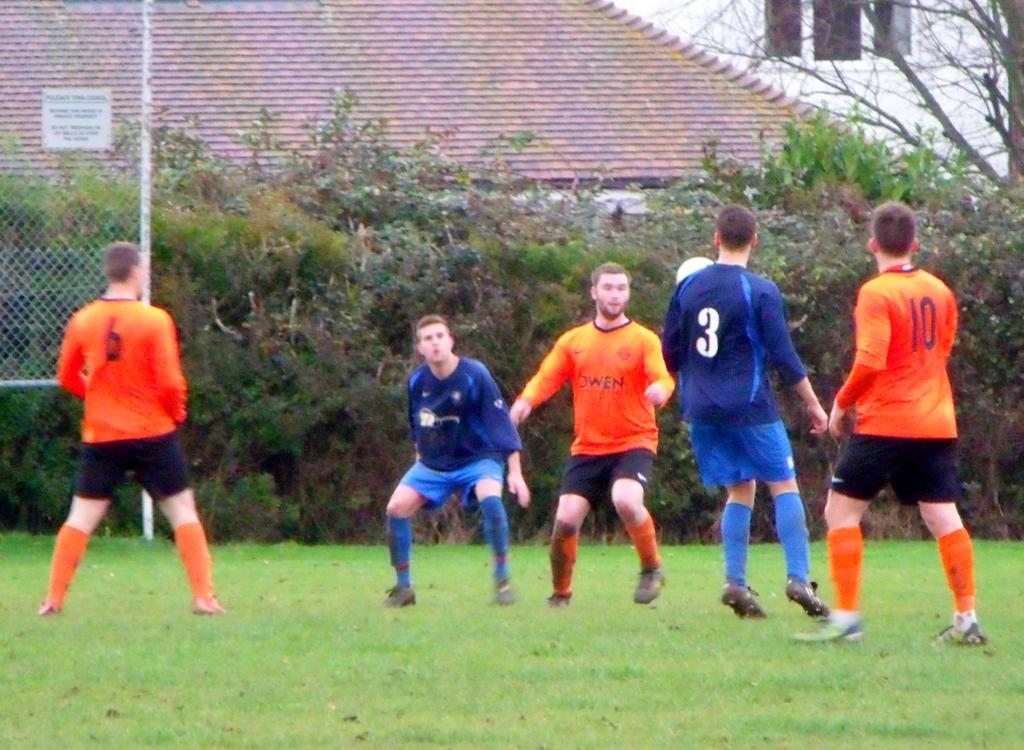<image>
Share a concise interpretation of the image provided. Some kids are playing soccer and one of them is named Owen. 